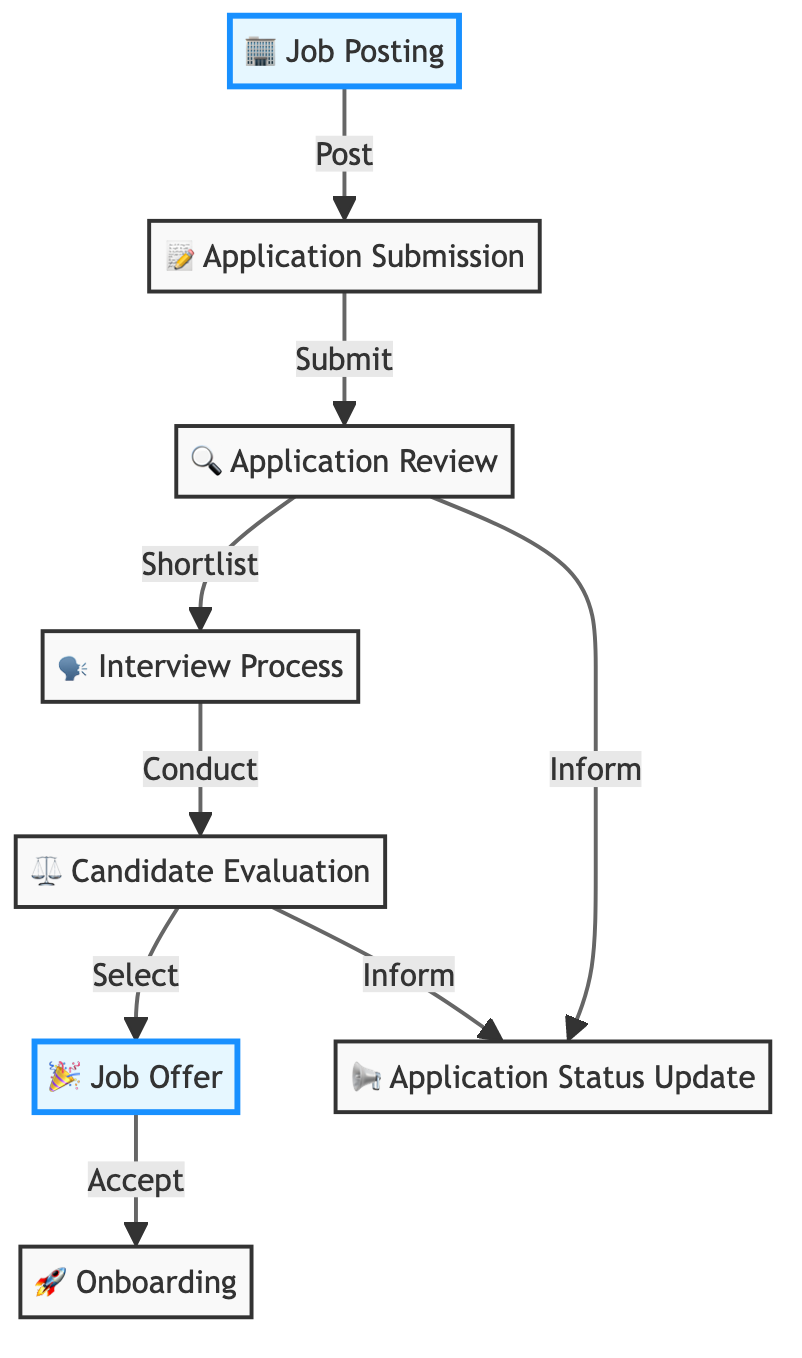What is the first step in the job application process? The first step, as indicated in the flowchart, is "Job Posting". It represents the starting point where the company advertises job openings.
Answer: Job Posting How many total steps are there in the application process? By counting the distinct steps displayed in the flowchart, we see there are a total of eight elements that represent different phases of the job application process.
Answer: Eight What happens after the Application Review? Following "Application Review", the next designated step is the "Interview Process". This indicates that shortlisted candidates are then invited for interviews.
Answer: Interview Process Which two nodes lead to the Application Status Update? The flowchart shows that both "Application Review" and "Candidate Evaluation" lead to the "Application Status Update". This means that status updates are informed based on the outcomes of these two processes.
Answer: Application Review and Candidate Evaluation What is the last step in the flow of the job application process? The final step in the flowchart, marked with the onboarding process, is "Onboarding". It signifies the conclusion of the hiring process once a candidate is accepted.
Answer: Onboarding What action leads from Candidate Evaluation to Job Offer? The flowchart shows that the action connecting "Candidate Evaluation" to "Job Offer" is "Select". This implies that candidates are selected based on their evaluation to receive a job offer.
Answer: Select How many nodes are highlighted in the flowchart? Upon inspecting the flowchart, we note that there are two highlighted nodes: "Job Posting" and "Job Offer". These are visually distinguished to emphasize these critical stages in the process.
Answer: Two Which step follows directly after Application Submission? The flowchart indicates that "Application Review" is the step that follows directly after "Application Submission". This shows the sequence of actions taken after a candidate has submitted their application.
Answer: Application Review What does the Job Offer step entail? The "Job Offer" step encompasses the act of extending a formal job offer to the selected candidate, including all relevant details about the position.
Answer: A formal job offer 